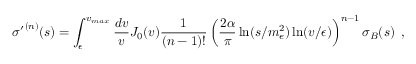<formula> <loc_0><loc_0><loc_500><loc_500>{ \sigma ^ { \prime } } ^ { ( n ) } ( s ) = \int _ { \epsilon } ^ { v _ { \max } } { \frac { d v } { v } } J _ { 0 } ( v ) { \frac { 1 } { ( n - 1 ) ! } } \left ( { \frac { 2 \alpha } { \pi } } \ln ( s / m _ { e } ^ { 2 } ) \ln ( v / \epsilon ) \right ) ^ { n - 1 } \sigma _ { B } ( s ) \, ,</formula> 